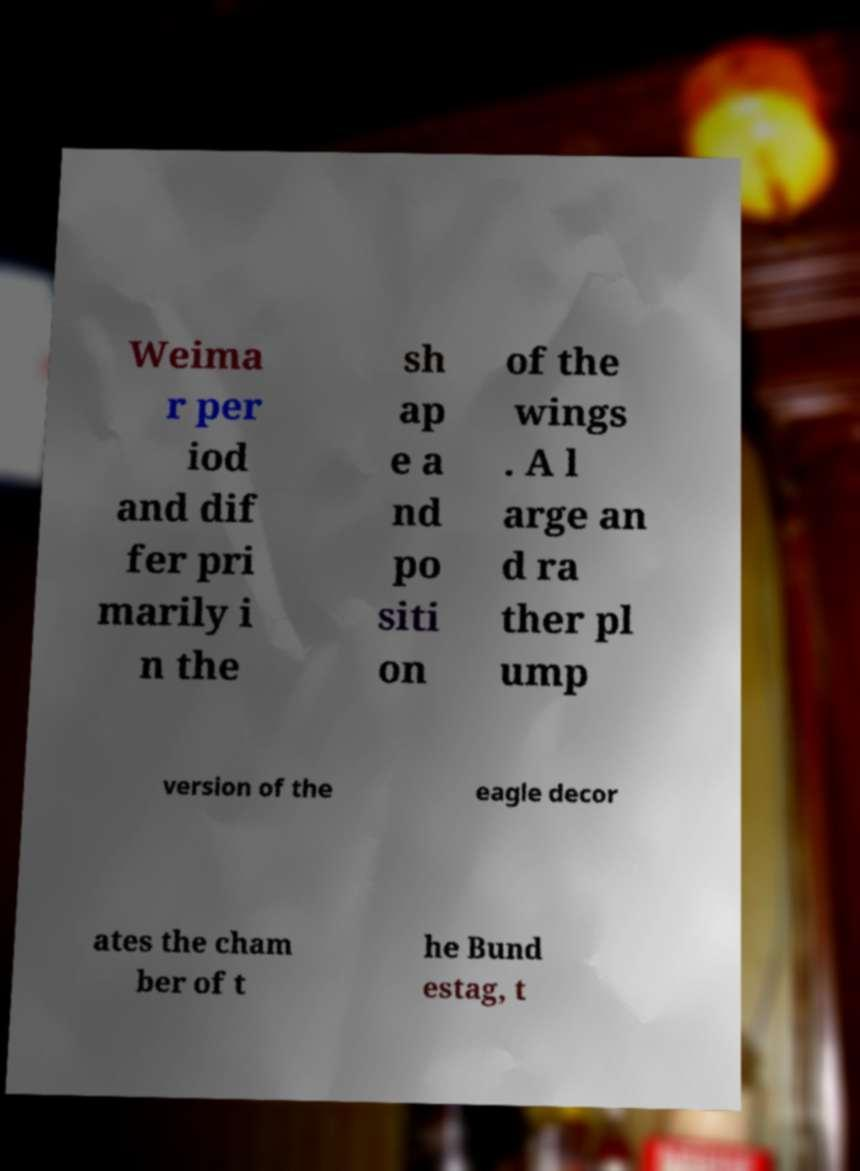Could you assist in decoding the text presented in this image and type it out clearly? Weima r per iod and dif fer pri marily i n the sh ap e a nd po siti on of the wings . A l arge an d ra ther pl ump version of the eagle decor ates the cham ber of t he Bund estag, t 